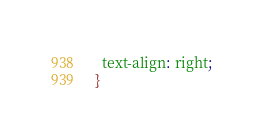Convert code to text. <code><loc_0><loc_0><loc_500><loc_500><_CSS_>  text-align: right;
}
</code> 